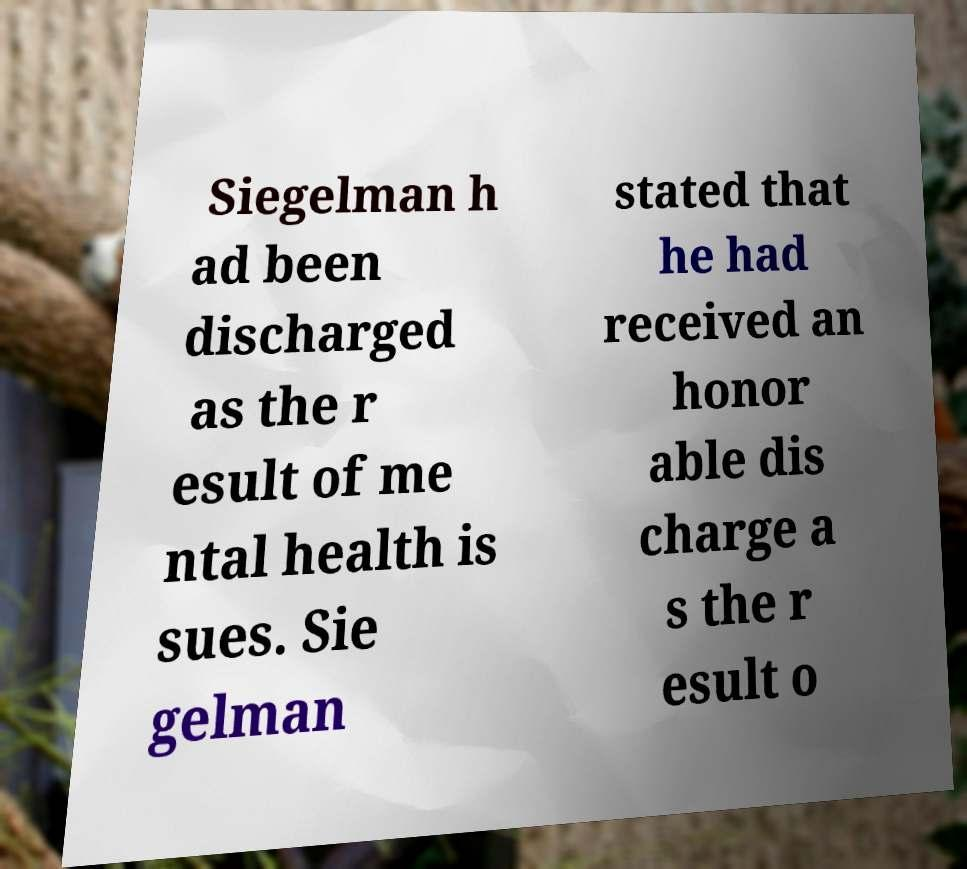Can you accurately transcribe the text from the provided image for me? Siegelman h ad been discharged as the r esult of me ntal health is sues. Sie gelman stated that he had received an honor able dis charge a s the r esult o 